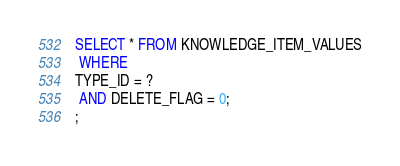<code> <loc_0><loc_0><loc_500><loc_500><_SQL_>SELECT * FROM KNOWLEDGE_ITEM_VALUES
 WHERE 
TYPE_ID = ?
 AND DELETE_FLAG = 0;
;
</code> 